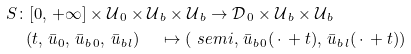<formula> <loc_0><loc_0><loc_500><loc_500>& S \colon [ 0 , \, + \infty ] \times \mathcal { U } _ { \, 0 } \times \mathcal { U } _ { \, b } \times \mathcal { U } _ { \, b } \to \mathcal { D } _ { \, 0 } \times \mathcal { U } _ { \, b } \times \mathcal { U } _ { \, b } \\ & \quad \, ( t , \, \bar { u } _ { 0 } , \, \bar { u } _ { b \, 0 } , \, \bar { u } _ { b \, l } ) \quad \, \mapsto \left ( \ s e m i , \, \bar { u } _ { b \, 0 } ( \, \cdot \, + t ) , \, \bar { u } _ { b \, l } ( \, \cdot \, + t ) \right ) \\</formula> 